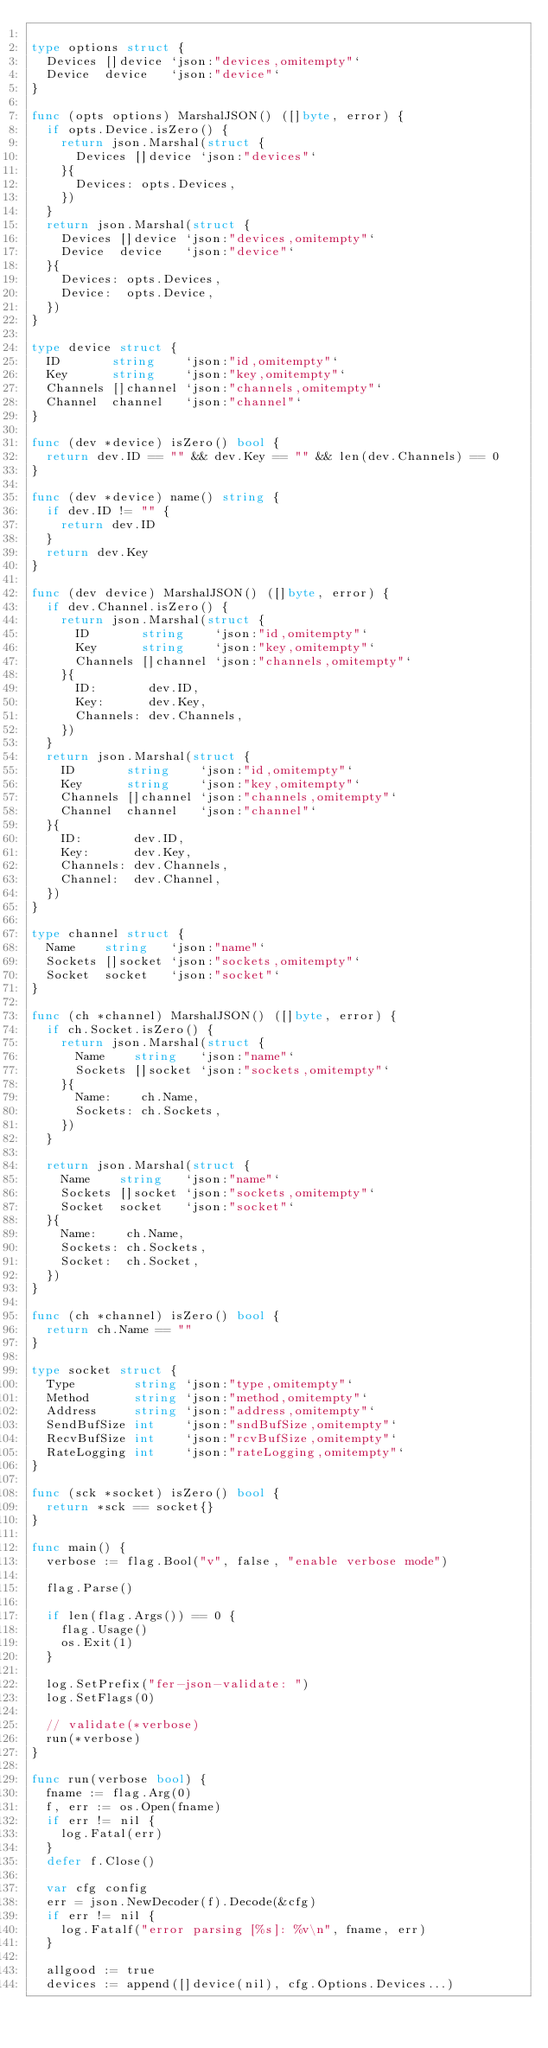Convert code to text. <code><loc_0><loc_0><loc_500><loc_500><_Go_>
type options struct {
	Devices []device `json:"devices,omitempty"`
	Device  device   `json:"device"`
}

func (opts options) MarshalJSON() ([]byte, error) {
	if opts.Device.isZero() {
		return json.Marshal(struct {
			Devices []device `json:"devices"`
		}{
			Devices: opts.Devices,
		})
	}
	return json.Marshal(struct {
		Devices []device `json:"devices,omitempty"`
		Device  device   `json:"device"`
	}{
		Devices: opts.Devices,
		Device:  opts.Device,
	})
}

type device struct {
	ID       string    `json:"id,omitempty"`
	Key      string    `json:"key,omitempty"`
	Channels []channel `json:"channels,omitempty"`
	Channel  channel   `json:"channel"`
}

func (dev *device) isZero() bool {
	return dev.ID == "" && dev.Key == "" && len(dev.Channels) == 0
}

func (dev *device) name() string {
	if dev.ID != "" {
		return dev.ID
	}
	return dev.Key
}

func (dev device) MarshalJSON() ([]byte, error) {
	if dev.Channel.isZero() {
		return json.Marshal(struct {
			ID       string    `json:"id,omitempty"`
			Key      string    `json:"key,omitempty"`
			Channels []channel `json:"channels,omitempty"`
		}{
			ID:       dev.ID,
			Key:      dev.Key,
			Channels: dev.Channels,
		})
	}
	return json.Marshal(struct {
		ID       string    `json:"id,omitempty"`
		Key      string    `json:"key,omitempty"`
		Channels []channel `json:"channels,omitempty"`
		Channel  channel   `json:"channel"`
	}{
		ID:       dev.ID,
		Key:      dev.Key,
		Channels: dev.Channels,
		Channel:  dev.Channel,
	})
}

type channel struct {
	Name    string   `json:"name"`
	Sockets []socket `json:"sockets,omitempty"`
	Socket  socket   `json:"socket"`
}

func (ch *channel) MarshalJSON() ([]byte, error) {
	if ch.Socket.isZero() {
		return json.Marshal(struct {
			Name    string   `json:"name"`
			Sockets []socket `json:"sockets,omitempty"`
		}{
			Name:    ch.Name,
			Sockets: ch.Sockets,
		})
	}

	return json.Marshal(struct {
		Name    string   `json:"name"`
		Sockets []socket `json:"sockets,omitempty"`
		Socket  socket   `json:"socket"`
	}{
		Name:    ch.Name,
		Sockets: ch.Sockets,
		Socket:  ch.Socket,
	})
}

func (ch *channel) isZero() bool {
	return ch.Name == ""
}

type socket struct {
	Type        string `json:"type,omitempty"`
	Method      string `json:"method,omitempty"`
	Address     string `json:"address,omitempty"`
	SendBufSize int    `json:"sndBufSize,omitempty"`
	RecvBufSize int    `json:"rcvBufSize,omitempty"`
	RateLogging int    `json:"rateLogging,omitempty"`
}

func (sck *socket) isZero() bool {
	return *sck == socket{}
}

func main() {
	verbose := flag.Bool("v", false, "enable verbose mode")

	flag.Parse()

	if len(flag.Args()) == 0 {
		flag.Usage()
		os.Exit(1)
	}

	log.SetPrefix("fer-json-validate: ")
	log.SetFlags(0)

	// validate(*verbose)
	run(*verbose)
}

func run(verbose bool) {
	fname := flag.Arg(0)
	f, err := os.Open(fname)
	if err != nil {
		log.Fatal(err)
	}
	defer f.Close()

	var cfg config
	err = json.NewDecoder(f).Decode(&cfg)
	if err != nil {
		log.Fatalf("error parsing [%s]: %v\n", fname, err)
	}

	allgood := true
	devices := append([]device(nil), cfg.Options.Devices...)</code> 